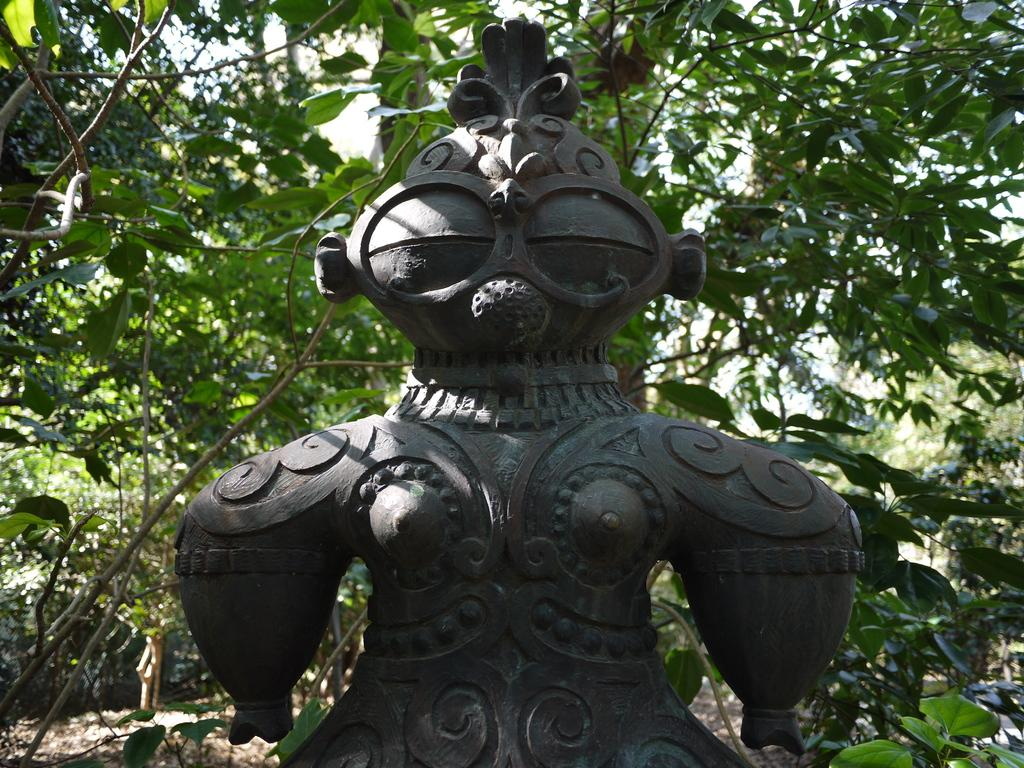What is the main subject in the foreground of the image? There is a statue in the foreground of the image. What can be seen in the background of the image? There are trees and the sky visible in the background of the image. How many pigs are visible in the image? There are no pigs present in the image. What type of flesh can be seen on the statue in the image? The statue is not made of flesh, and there is no flesh visible in the image. 